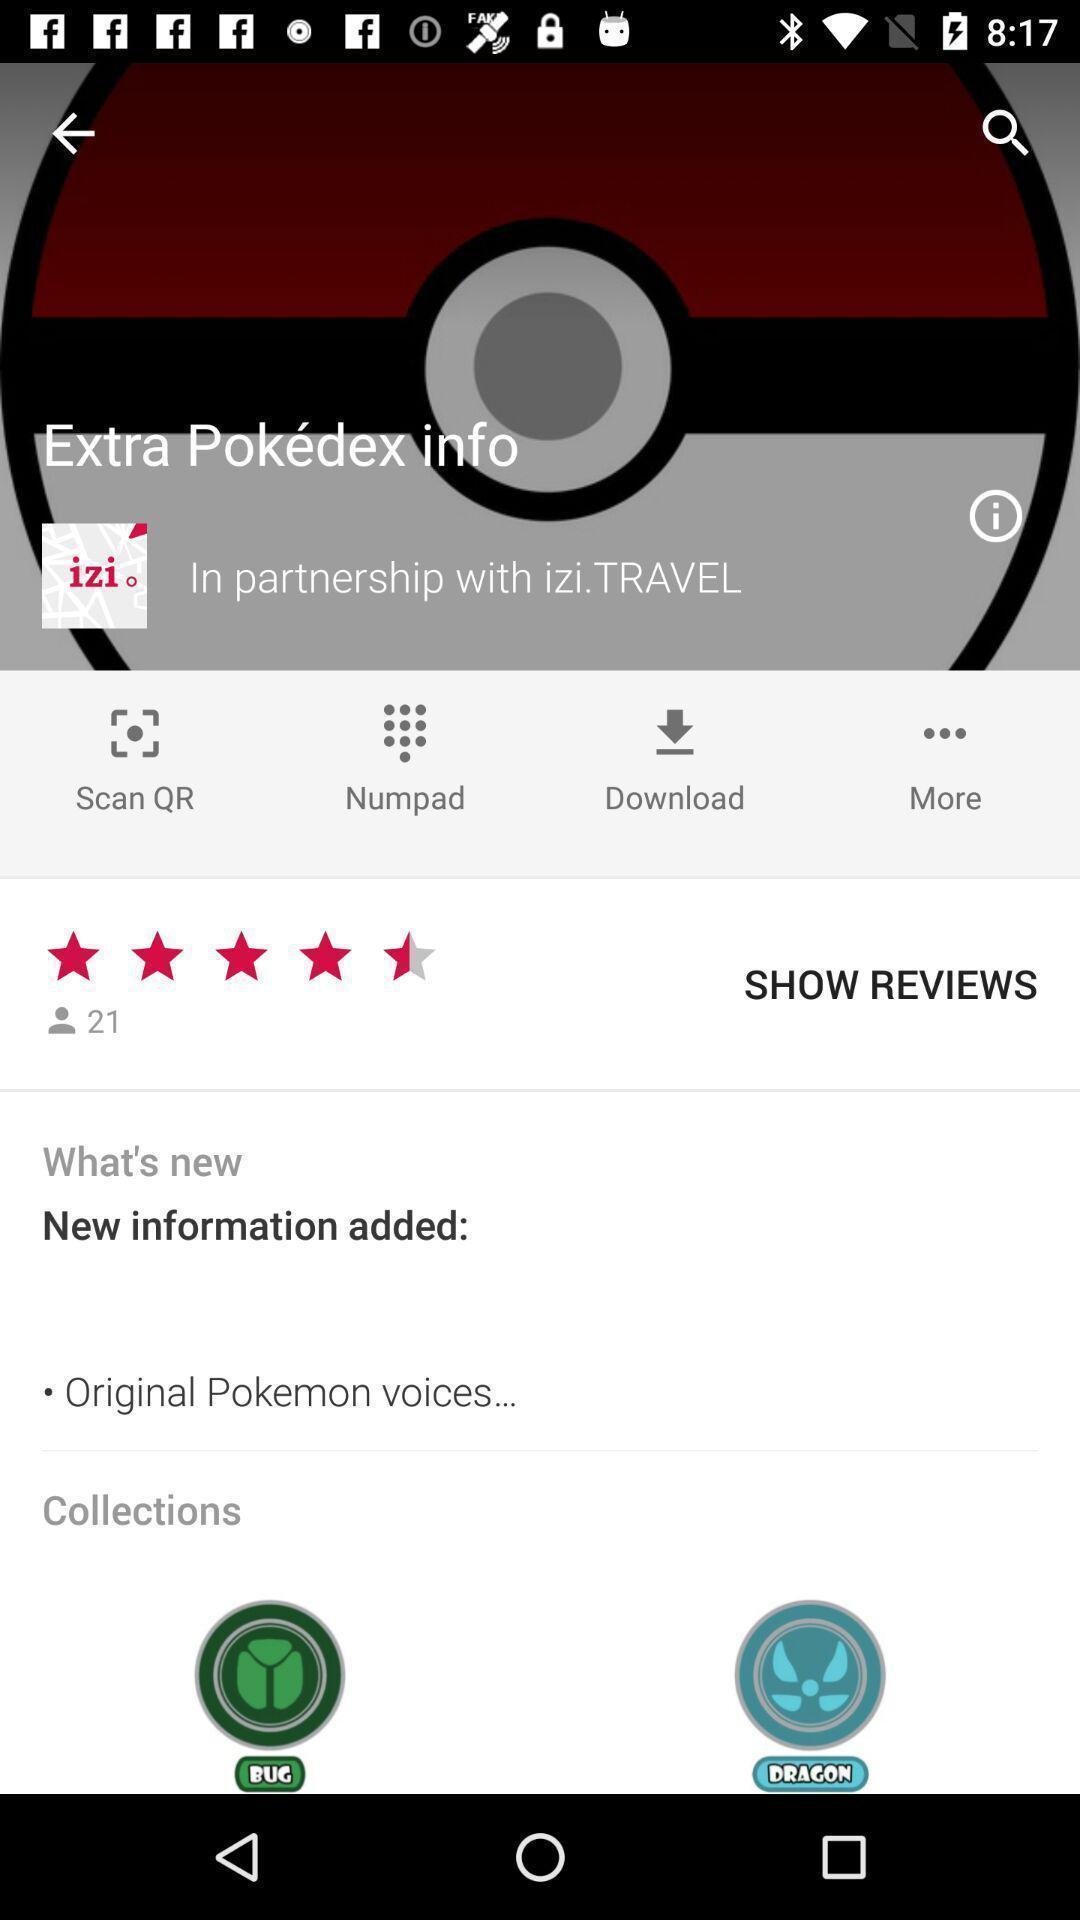Explain the elements present in this screenshot. Page showing to select tour guide. 